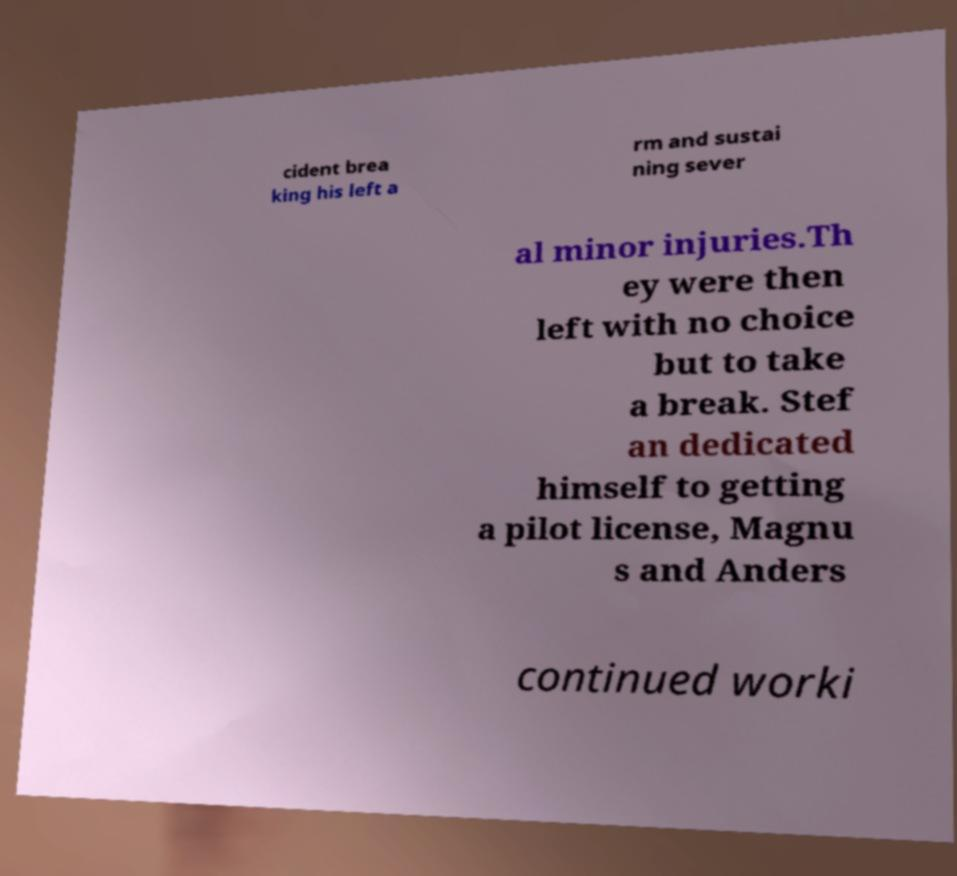Can you accurately transcribe the text from the provided image for me? cident brea king his left a rm and sustai ning sever al minor injuries.Th ey were then left with no choice but to take a break. Stef an dedicated himself to getting a pilot license, Magnu s and Anders continued worki 